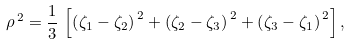<formula> <loc_0><loc_0><loc_500><loc_500>\rho ^ { \, 2 } = \frac { 1 } { 3 } \, \left [ \left ( \zeta _ { 1 } - \zeta _ { 2 } \right ) ^ { \, 2 } + \left ( \zeta _ { 2 } - \zeta _ { 3 } \right ) ^ { \, 2 } + \left ( \zeta _ { 3 } - \zeta _ { 1 } \right ) ^ { \, 2 } \right ] ,</formula> 